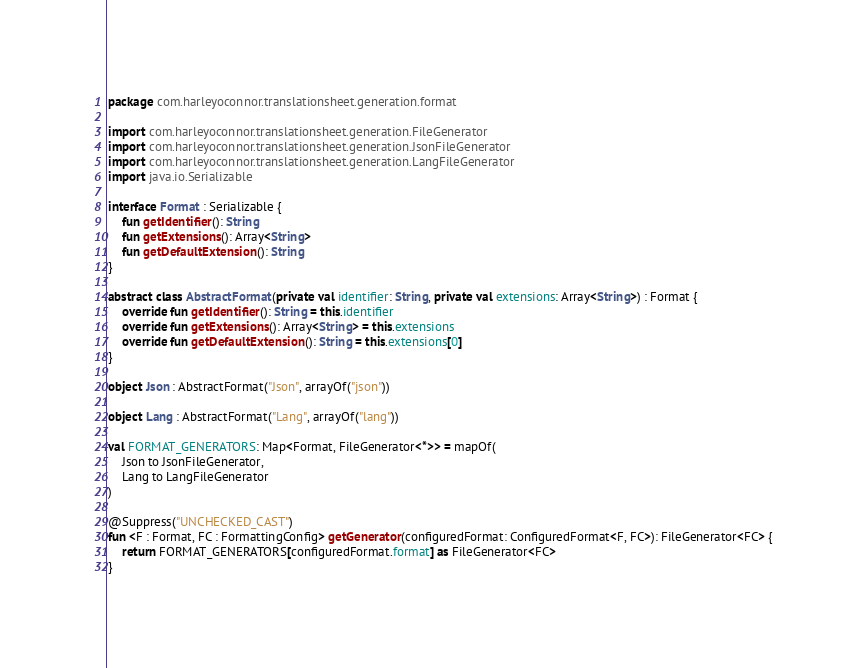Convert code to text. <code><loc_0><loc_0><loc_500><loc_500><_Kotlin_>package com.harleyoconnor.translationsheet.generation.format

import com.harleyoconnor.translationsheet.generation.FileGenerator
import com.harleyoconnor.translationsheet.generation.JsonFileGenerator
import com.harleyoconnor.translationsheet.generation.LangFileGenerator
import java.io.Serializable

interface Format : Serializable {
    fun getIdentifier(): String
    fun getExtensions(): Array<String>
    fun getDefaultExtension(): String
}

abstract class AbstractFormat(private val identifier: String, private val extensions: Array<String>) : Format {
    override fun getIdentifier(): String = this.identifier
    override fun getExtensions(): Array<String> = this.extensions
    override fun getDefaultExtension(): String = this.extensions[0]
}

object Json : AbstractFormat("Json", arrayOf("json"))

object Lang : AbstractFormat("Lang", arrayOf("lang"))

val FORMAT_GENERATORS: Map<Format, FileGenerator<*>> = mapOf(
    Json to JsonFileGenerator,
    Lang to LangFileGenerator
)

@Suppress("UNCHECKED_CAST")
fun <F : Format, FC : FormattingConfig> getGenerator(configuredFormat: ConfiguredFormat<F, FC>): FileGenerator<FC> {
    return FORMAT_GENERATORS[configuredFormat.format] as FileGenerator<FC>
}
</code> 